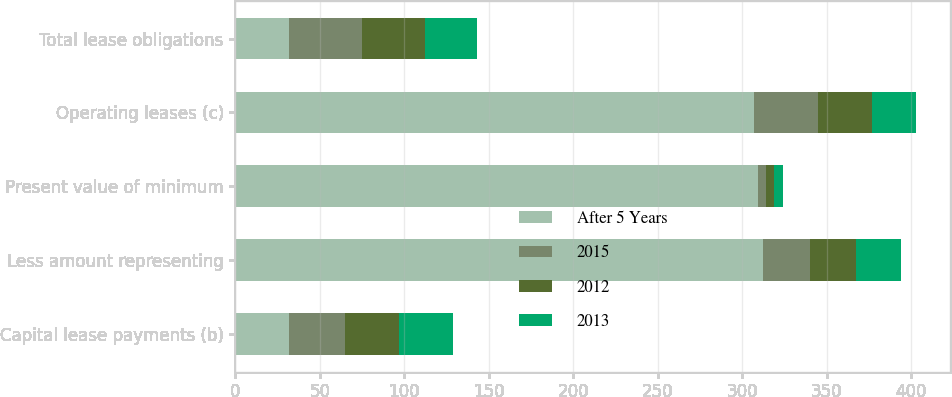<chart> <loc_0><loc_0><loc_500><loc_500><stacked_bar_chart><ecel><fcel>Capital lease payments (b)<fcel>Less amount representing<fcel>Present value of minimum<fcel>Operating leases (c)<fcel>Total lease obligations<nl><fcel>After 5 Years<fcel>32<fcel>312<fcel>309<fcel>307<fcel>32<nl><fcel>2015<fcel>33<fcel>28<fcel>5<fcel>38<fcel>43<nl><fcel>2012<fcel>32<fcel>27<fcel>5<fcel>32<fcel>37<nl><fcel>2013<fcel>32<fcel>27<fcel>5<fcel>26<fcel>31<nl></chart> 